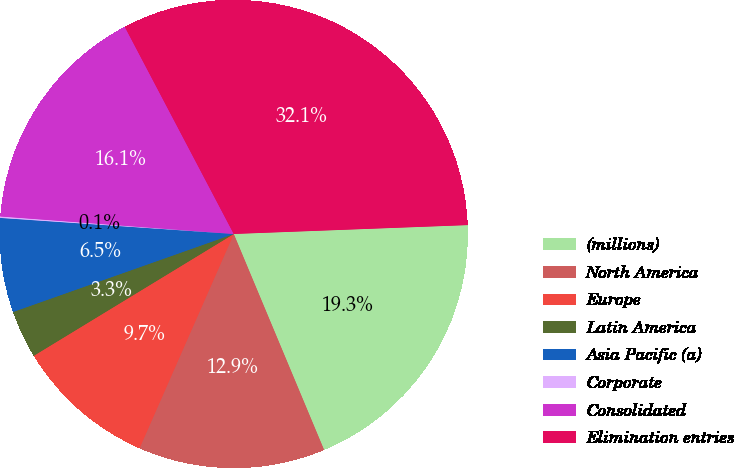Convert chart to OTSL. <chart><loc_0><loc_0><loc_500><loc_500><pie_chart><fcel>(millions)<fcel>North America<fcel>Europe<fcel>Latin America<fcel>Asia Pacific (a)<fcel>Corporate<fcel>Consolidated<fcel>Elimination entries<nl><fcel>19.3%<fcel>12.9%<fcel>9.7%<fcel>3.3%<fcel>6.5%<fcel>0.1%<fcel>16.1%<fcel>32.11%<nl></chart> 